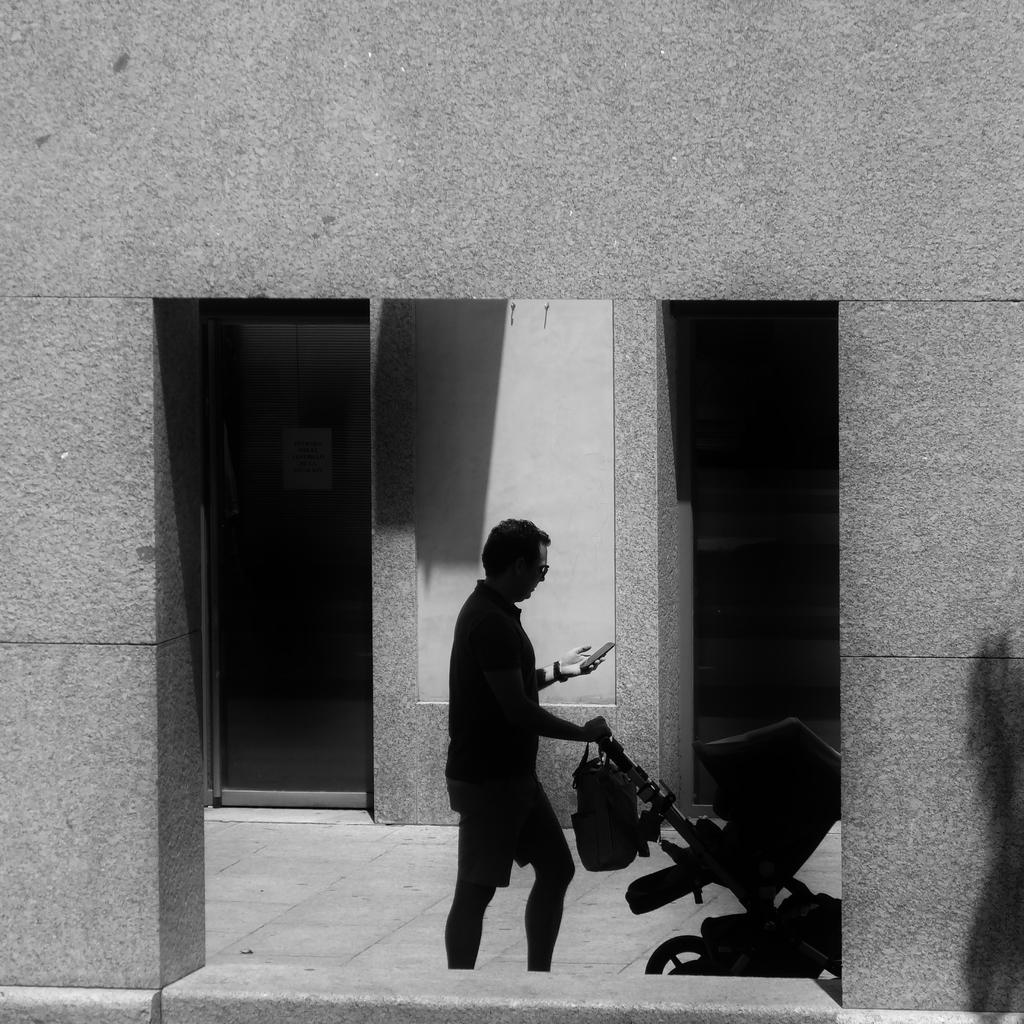What is the color scheme of the image? The image is black and white. What is the person in the image doing? The person is standing and holding a stroller and a mobile. What can be seen in the background of the image? There is a building in the background of the image. Can you tell me how many flights are visible in the image? There are no flights visible in the image, as it is a black and white image of a person holding a stroller and a mobile with a building in the background. What type of appliance is being used by the person in the image? There is no appliance being used by the person in the image; they are holding a stroller and a mobile. 